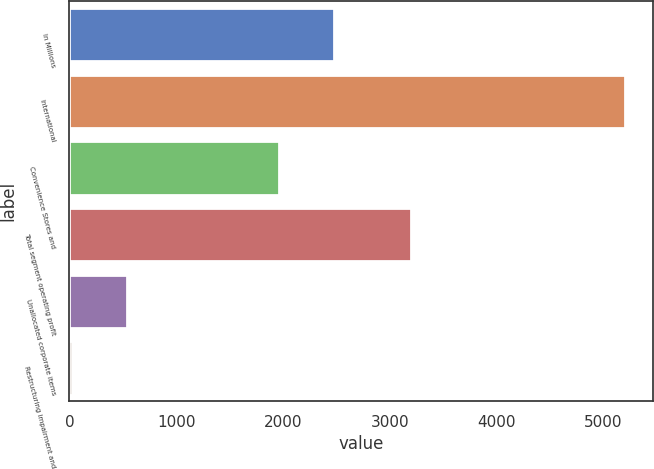Convert chart. <chart><loc_0><loc_0><loc_500><loc_500><bar_chart><fcel>In Millions<fcel>International<fcel>Convenience Stores and<fcel>Total segment operating profit<fcel>Unallocated corporate items<fcel>Restructuring impairment and<nl><fcel>2477.04<fcel>5200.2<fcel>1959<fcel>3197.7<fcel>537.84<fcel>19.8<nl></chart> 